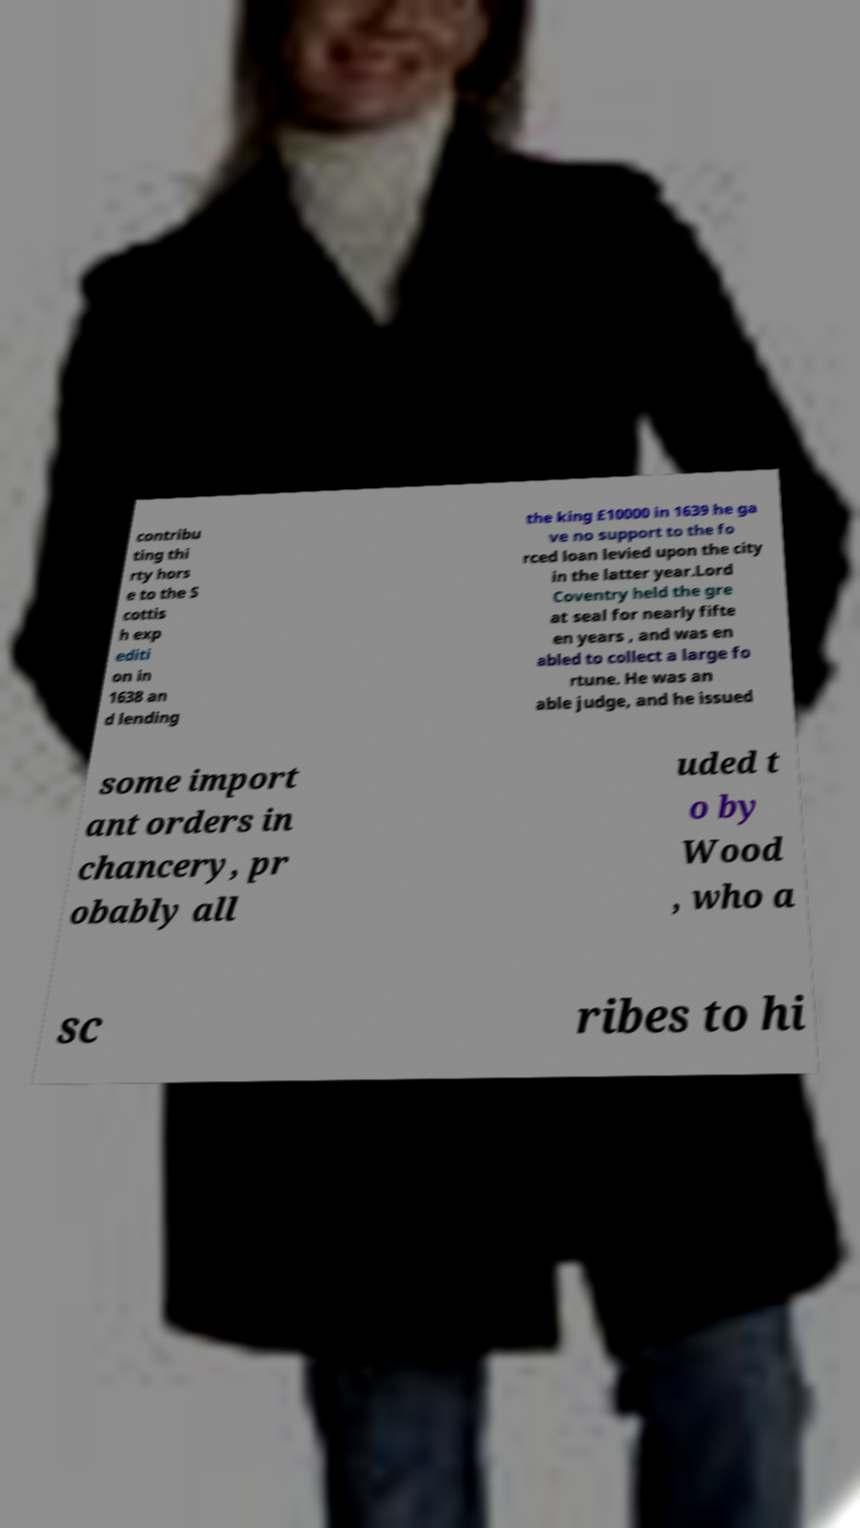Please identify and transcribe the text found in this image. contribu ting thi rty hors e to the S cottis h exp editi on in 1638 an d lending the king £10000 in 1639 he ga ve no support to the fo rced loan levied upon the city in the latter year.Lord Coventry held the gre at seal for nearly fifte en years , and was en abled to collect a large fo rtune. He was an able judge, and he issued some import ant orders in chancery, pr obably all uded t o by Wood , who a sc ribes to hi 